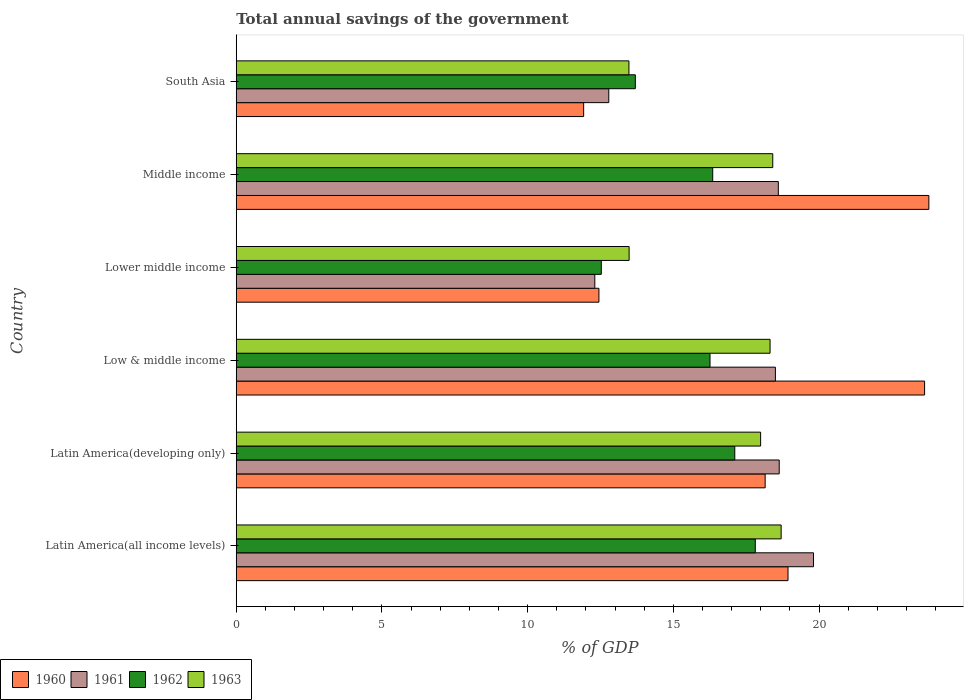How many groups of bars are there?
Offer a terse response. 6. Are the number of bars on each tick of the Y-axis equal?
Ensure brevity in your answer.  Yes. How many bars are there on the 4th tick from the top?
Your answer should be very brief. 4. What is the label of the 5th group of bars from the top?
Offer a terse response. Latin America(developing only). In how many cases, is the number of bars for a given country not equal to the number of legend labels?
Provide a succinct answer. 0. What is the total annual savings of the government in 1961 in Middle income?
Provide a succinct answer. 18.6. Across all countries, what is the maximum total annual savings of the government in 1962?
Offer a terse response. 17.81. Across all countries, what is the minimum total annual savings of the government in 1963?
Your response must be concise. 13.48. In which country was the total annual savings of the government in 1963 maximum?
Your response must be concise. Latin America(all income levels). In which country was the total annual savings of the government in 1963 minimum?
Ensure brevity in your answer.  South Asia. What is the total total annual savings of the government in 1960 in the graph?
Provide a short and direct response. 108.84. What is the difference between the total annual savings of the government in 1961 in Latin America(all income levels) and that in Lower middle income?
Provide a succinct answer. 7.5. What is the difference between the total annual savings of the government in 1962 in South Asia and the total annual savings of the government in 1960 in Latin America(all income levels)?
Give a very brief answer. -5.24. What is the average total annual savings of the government in 1961 per country?
Give a very brief answer. 16.77. What is the difference between the total annual savings of the government in 1963 and total annual savings of the government in 1962 in South Asia?
Your answer should be very brief. -0.22. In how many countries, is the total annual savings of the government in 1962 greater than 18 %?
Your answer should be very brief. 0. What is the ratio of the total annual savings of the government in 1960 in Latin America(all income levels) to that in Latin America(developing only)?
Keep it short and to the point. 1.04. Is the difference between the total annual savings of the government in 1963 in Latin America(developing only) and Low & middle income greater than the difference between the total annual savings of the government in 1962 in Latin America(developing only) and Low & middle income?
Ensure brevity in your answer.  No. What is the difference between the highest and the second highest total annual savings of the government in 1961?
Provide a succinct answer. 1.18. What is the difference between the highest and the lowest total annual savings of the government in 1960?
Give a very brief answer. 11.85. Is the sum of the total annual savings of the government in 1961 in Latin America(all income levels) and Latin America(developing only) greater than the maximum total annual savings of the government in 1960 across all countries?
Your response must be concise. Yes. What does the 3rd bar from the bottom in South Asia represents?
Your answer should be compact. 1962. Is it the case that in every country, the sum of the total annual savings of the government in 1963 and total annual savings of the government in 1961 is greater than the total annual savings of the government in 1960?
Make the answer very short. Yes. How many bars are there?
Your answer should be compact. 24. How many countries are there in the graph?
Your response must be concise. 6. What is the difference between two consecutive major ticks on the X-axis?
Your answer should be very brief. 5. What is the title of the graph?
Keep it short and to the point. Total annual savings of the government. Does "1990" appear as one of the legend labels in the graph?
Make the answer very short. No. What is the label or title of the X-axis?
Ensure brevity in your answer.  % of GDP. What is the % of GDP of 1960 in Latin America(all income levels)?
Offer a terse response. 18.93. What is the % of GDP in 1961 in Latin America(all income levels)?
Offer a very short reply. 19.81. What is the % of GDP in 1962 in Latin America(all income levels)?
Your answer should be compact. 17.81. What is the % of GDP in 1963 in Latin America(all income levels)?
Ensure brevity in your answer.  18.7. What is the % of GDP of 1960 in Latin America(developing only)?
Your response must be concise. 18.15. What is the % of GDP in 1961 in Latin America(developing only)?
Keep it short and to the point. 18.63. What is the % of GDP in 1962 in Latin America(developing only)?
Your response must be concise. 17.11. What is the % of GDP of 1963 in Latin America(developing only)?
Ensure brevity in your answer.  17.99. What is the % of GDP of 1960 in Low & middle income?
Your answer should be compact. 23.62. What is the % of GDP of 1961 in Low & middle income?
Your answer should be very brief. 18.5. What is the % of GDP in 1962 in Low & middle income?
Provide a short and direct response. 16.26. What is the % of GDP in 1963 in Low & middle income?
Ensure brevity in your answer.  18.32. What is the % of GDP of 1960 in Lower middle income?
Your answer should be very brief. 12.45. What is the % of GDP in 1961 in Lower middle income?
Give a very brief answer. 12.3. What is the % of GDP in 1962 in Lower middle income?
Make the answer very short. 12.53. What is the % of GDP in 1963 in Lower middle income?
Give a very brief answer. 13.48. What is the % of GDP in 1960 in Middle income?
Keep it short and to the point. 23.77. What is the % of GDP of 1961 in Middle income?
Keep it short and to the point. 18.6. What is the % of GDP of 1962 in Middle income?
Your response must be concise. 16.35. What is the % of GDP of 1963 in Middle income?
Make the answer very short. 18.41. What is the % of GDP in 1960 in South Asia?
Provide a succinct answer. 11.92. What is the % of GDP in 1961 in South Asia?
Provide a short and direct response. 12.78. What is the % of GDP of 1962 in South Asia?
Give a very brief answer. 13.69. What is the % of GDP in 1963 in South Asia?
Offer a terse response. 13.48. Across all countries, what is the maximum % of GDP in 1960?
Ensure brevity in your answer.  23.77. Across all countries, what is the maximum % of GDP in 1961?
Offer a terse response. 19.81. Across all countries, what is the maximum % of GDP in 1962?
Provide a succinct answer. 17.81. Across all countries, what is the maximum % of GDP of 1963?
Provide a short and direct response. 18.7. Across all countries, what is the minimum % of GDP in 1960?
Provide a short and direct response. 11.92. Across all countries, what is the minimum % of GDP in 1961?
Make the answer very short. 12.3. Across all countries, what is the minimum % of GDP in 1962?
Your answer should be compact. 12.53. Across all countries, what is the minimum % of GDP of 1963?
Ensure brevity in your answer.  13.48. What is the total % of GDP of 1960 in the graph?
Make the answer very short. 108.84. What is the total % of GDP of 1961 in the graph?
Make the answer very short. 100.64. What is the total % of GDP of 1962 in the graph?
Make the answer very short. 93.75. What is the total % of GDP of 1963 in the graph?
Provide a short and direct response. 100.38. What is the difference between the % of GDP of 1960 in Latin America(all income levels) and that in Latin America(developing only)?
Make the answer very short. 0.78. What is the difference between the % of GDP of 1961 in Latin America(all income levels) and that in Latin America(developing only)?
Make the answer very short. 1.18. What is the difference between the % of GDP of 1962 in Latin America(all income levels) and that in Latin America(developing only)?
Make the answer very short. 0.7. What is the difference between the % of GDP in 1963 in Latin America(all income levels) and that in Latin America(developing only)?
Keep it short and to the point. 0.7. What is the difference between the % of GDP of 1960 in Latin America(all income levels) and that in Low & middle income?
Ensure brevity in your answer.  -4.69. What is the difference between the % of GDP in 1961 in Latin America(all income levels) and that in Low & middle income?
Make the answer very short. 1.31. What is the difference between the % of GDP in 1962 in Latin America(all income levels) and that in Low & middle income?
Offer a very short reply. 1.55. What is the difference between the % of GDP in 1963 in Latin America(all income levels) and that in Low & middle income?
Provide a short and direct response. 0.38. What is the difference between the % of GDP of 1960 in Latin America(all income levels) and that in Lower middle income?
Keep it short and to the point. 6.49. What is the difference between the % of GDP in 1961 in Latin America(all income levels) and that in Lower middle income?
Make the answer very short. 7.5. What is the difference between the % of GDP in 1962 in Latin America(all income levels) and that in Lower middle income?
Make the answer very short. 5.28. What is the difference between the % of GDP of 1963 in Latin America(all income levels) and that in Lower middle income?
Provide a succinct answer. 5.22. What is the difference between the % of GDP in 1960 in Latin America(all income levels) and that in Middle income?
Provide a short and direct response. -4.83. What is the difference between the % of GDP in 1961 in Latin America(all income levels) and that in Middle income?
Keep it short and to the point. 1.21. What is the difference between the % of GDP of 1962 in Latin America(all income levels) and that in Middle income?
Ensure brevity in your answer.  1.46. What is the difference between the % of GDP in 1963 in Latin America(all income levels) and that in Middle income?
Make the answer very short. 0.29. What is the difference between the % of GDP of 1960 in Latin America(all income levels) and that in South Asia?
Give a very brief answer. 7.01. What is the difference between the % of GDP in 1961 in Latin America(all income levels) and that in South Asia?
Provide a short and direct response. 7.03. What is the difference between the % of GDP of 1962 in Latin America(all income levels) and that in South Asia?
Provide a short and direct response. 4.12. What is the difference between the % of GDP in 1963 in Latin America(all income levels) and that in South Asia?
Offer a terse response. 5.22. What is the difference between the % of GDP in 1960 in Latin America(developing only) and that in Low & middle income?
Offer a very short reply. -5.47. What is the difference between the % of GDP in 1961 in Latin America(developing only) and that in Low & middle income?
Offer a terse response. 0.13. What is the difference between the % of GDP of 1962 in Latin America(developing only) and that in Low & middle income?
Your answer should be very brief. 0.85. What is the difference between the % of GDP in 1963 in Latin America(developing only) and that in Low & middle income?
Keep it short and to the point. -0.32. What is the difference between the % of GDP in 1960 in Latin America(developing only) and that in Lower middle income?
Your response must be concise. 5.7. What is the difference between the % of GDP in 1961 in Latin America(developing only) and that in Lower middle income?
Your answer should be very brief. 6.33. What is the difference between the % of GDP in 1962 in Latin America(developing only) and that in Lower middle income?
Offer a terse response. 4.58. What is the difference between the % of GDP in 1963 in Latin America(developing only) and that in Lower middle income?
Ensure brevity in your answer.  4.51. What is the difference between the % of GDP of 1960 in Latin America(developing only) and that in Middle income?
Offer a terse response. -5.62. What is the difference between the % of GDP in 1961 in Latin America(developing only) and that in Middle income?
Ensure brevity in your answer.  0.03. What is the difference between the % of GDP of 1962 in Latin America(developing only) and that in Middle income?
Your answer should be very brief. 0.76. What is the difference between the % of GDP in 1963 in Latin America(developing only) and that in Middle income?
Keep it short and to the point. -0.42. What is the difference between the % of GDP in 1960 in Latin America(developing only) and that in South Asia?
Your answer should be compact. 6.23. What is the difference between the % of GDP of 1961 in Latin America(developing only) and that in South Asia?
Keep it short and to the point. 5.85. What is the difference between the % of GDP of 1962 in Latin America(developing only) and that in South Asia?
Your response must be concise. 3.41. What is the difference between the % of GDP of 1963 in Latin America(developing only) and that in South Asia?
Your response must be concise. 4.52. What is the difference between the % of GDP in 1960 in Low & middle income and that in Lower middle income?
Your answer should be compact. 11.18. What is the difference between the % of GDP of 1961 in Low & middle income and that in Lower middle income?
Provide a short and direct response. 6.2. What is the difference between the % of GDP in 1962 in Low & middle income and that in Lower middle income?
Ensure brevity in your answer.  3.73. What is the difference between the % of GDP of 1963 in Low & middle income and that in Lower middle income?
Your response must be concise. 4.84. What is the difference between the % of GDP in 1960 in Low & middle income and that in Middle income?
Your answer should be compact. -0.15. What is the difference between the % of GDP in 1961 in Low & middle income and that in Middle income?
Your response must be concise. -0.1. What is the difference between the % of GDP in 1962 in Low & middle income and that in Middle income?
Provide a short and direct response. -0.09. What is the difference between the % of GDP of 1963 in Low & middle income and that in Middle income?
Give a very brief answer. -0.09. What is the difference between the % of GDP in 1960 in Low & middle income and that in South Asia?
Your answer should be compact. 11.7. What is the difference between the % of GDP of 1961 in Low & middle income and that in South Asia?
Make the answer very short. 5.72. What is the difference between the % of GDP in 1962 in Low & middle income and that in South Asia?
Ensure brevity in your answer.  2.56. What is the difference between the % of GDP in 1963 in Low & middle income and that in South Asia?
Offer a very short reply. 4.84. What is the difference between the % of GDP of 1960 in Lower middle income and that in Middle income?
Give a very brief answer. -11.32. What is the difference between the % of GDP of 1961 in Lower middle income and that in Middle income?
Your answer should be compact. -6.3. What is the difference between the % of GDP of 1962 in Lower middle income and that in Middle income?
Keep it short and to the point. -3.82. What is the difference between the % of GDP in 1963 in Lower middle income and that in Middle income?
Your answer should be compact. -4.93. What is the difference between the % of GDP of 1960 in Lower middle income and that in South Asia?
Keep it short and to the point. 0.52. What is the difference between the % of GDP in 1961 in Lower middle income and that in South Asia?
Offer a terse response. -0.48. What is the difference between the % of GDP in 1962 in Lower middle income and that in South Asia?
Your answer should be compact. -1.17. What is the difference between the % of GDP of 1963 in Lower middle income and that in South Asia?
Give a very brief answer. 0.01. What is the difference between the % of GDP in 1960 in Middle income and that in South Asia?
Provide a succinct answer. 11.85. What is the difference between the % of GDP of 1961 in Middle income and that in South Asia?
Offer a terse response. 5.82. What is the difference between the % of GDP of 1962 in Middle income and that in South Asia?
Provide a short and direct response. 2.66. What is the difference between the % of GDP of 1963 in Middle income and that in South Asia?
Make the answer very short. 4.94. What is the difference between the % of GDP in 1960 in Latin America(all income levels) and the % of GDP in 1961 in Latin America(developing only)?
Your response must be concise. 0.3. What is the difference between the % of GDP of 1960 in Latin America(all income levels) and the % of GDP of 1962 in Latin America(developing only)?
Give a very brief answer. 1.83. What is the difference between the % of GDP in 1960 in Latin America(all income levels) and the % of GDP in 1963 in Latin America(developing only)?
Your response must be concise. 0.94. What is the difference between the % of GDP in 1961 in Latin America(all income levels) and the % of GDP in 1962 in Latin America(developing only)?
Provide a short and direct response. 2.7. What is the difference between the % of GDP in 1961 in Latin America(all income levels) and the % of GDP in 1963 in Latin America(developing only)?
Make the answer very short. 1.81. What is the difference between the % of GDP in 1962 in Latin America(all income levels) and the % of GDP in 1963 in Latin America(developing only)?
Provide a short and direct response. -0.18. What is the difference between the % of GDP of 1960 in Latin America(all income levels) and the % of GDP of 1961 in Low & middle income?
Ensure brevity in your answer.  0.43. What is the difference between the % of GDP in 1960 in Latin America(all income levels) and the % of GDP in 1962 in Low & middle income?
Keep it short and to the point. 2.68. What is the difference between the % of GDP in 1960 in Latin America(all income levels) and the % of GDP in 1963 in Low & middle income?
Give a very brief answer. 0.62. What is the difference between the % of GDP of 1961 in Latin America(all income levels) and the % of GDP of 1962 in Low & middle income?
Your answer should be very brief. 3.55. What is the difference between the % of GDP in 1961 in Latin America(all income levels) and the % of GDP in 1963 in Low & middle income?
Your answer should be very brief. 1.49. What is the difference between the % of GDP in 1962 in Latin America(all income levels) and the % of GDP in 1963 in Low & middle income?
Give a very brief answer. -0.51. What is the difference between the % of GDP in 1960 in Latin America(all income levels) and the % of GDP in 1961 in Lower middle income?
Your answer should be compact. 6.63. What is the difference between the % of GDP in 1960 in Latin America(all income levels) and the % of GDP in 1962 in Lower middle income?
Offer a very short reply. 6.41. What is the difference between the % of GDP in 1960 in Latin America(all income levels) and the % of GDP in 1963 in Lower middle income?
Keep it short and to the point. 5.45. What is the difference between the % of GDP in 1961 in Latin America(all income levels) and the % of GDP in 1962 in Lower middle income?
Make the answer very short. 7.28. What is the difference between the % of GDP in 1961 in Latin America(all income levels) and the % of GDP in 1963 in Lower middle income?
Your answer should be compact. 6.33. What is the difference between the % of GDP of 1962 in Latin America(all income levels) and the % of GDP of 1963 in Lower middle income?
Your answer should be compact. 4.33. What is the difference between the % of GDP of 1960 in Latin America(all income levels) and the % of GDP of 1961 in Middle income?
Your answer should be very brief. 0.33. What is the difference between the % of GDP in 1960 in Latin America(all income levels) and the % of GDP in 1962 in Middle income?
Offer a terse response. 2.58. What is the difference between the % of GDP in 1960 in Latin America(all income levels) and the % of GDP in 1963 in Middle income?
Your response must be concise. 0.52. What is the difference between the % of GDP of 1961 in Latin America(all income levels) and the % of GDP of 1962 in Middle income?
Offer a very short reply. 3.46. What is the difference between the % of GDP of 1961 in Latin America(all income levels) and the % of GDP of 1963 in Middle income?
Your response must be concise. 1.4. What is the difference between the % of GDP of 1962 in Latin America(all income levels) and the % of GDP of 1963 in Middle income?
Offer a very short reply. -0.6. What is the difference between the % of GDP of 1960 in Latin America(all income levels) and the % of GDP of 1961 in South Asia?
Make the answer very short. 6.15. What is the difference between the % of GDP in 1960 in Latin America(all income levels) and the % of GDP in 1962 in South Asia?
Ensure brevity in your answer.  5.24. What is the difference between the % of GDP of 1960 in Latin America(all income levels) and the % of GDP of 1963 in South Asia?
Ensure brevity in your answer.  5.46. What is the difference between the % of GDP in 1961 in Latin America(all income levels) and the % of GDP in 1962 in South Asia?
Offer a very short reply. 6.11. What is the difference between the % of GDP in 1961 in Latin America(all income levels) and the % of GDP in 1963 in South Asia?
Offer a terse response. 6.33. What is the difference between the % of GDP in 1962 in Latin America(all income levels) and the % of GDP in 1963 in South Asia?
Your response must be concise. 4.34. What is the difference between the % of GDP of 1960 in Latin America(developing only) and the % of GDP of 1961 in Low & middle income?
Ensure brevity in your answer.  -0.35. What is the difference between the % of GDP of 1960 in Latin America(developing only) and the % of GDP of 1962 in Low & middle income?
Your answer should be very brief. 1.89. What is the difference between the % of GDP in 1960 in Latin America(developing only) and the % of GDP in 1963 in Low & middle income?
Your answer should be compact. -0.17. What is the difference between the % of GDP of 1961 in Latin America(developing only) and the % of GDP of 1962 in Low & middle income?
Offer a terse response. 2.37. What is the difference between the % of GDP of 1961 in Latin America(developing only) and the % of GDP of 1963 in Low & middle income?
Provide a short and direct response. 0.31. What is the difference between the % of GDP of 1962 in Latin America(developing only) and the % of GDP of 1963 in Low & middle income?
Make the answer very short. -1.21. What is the difference between the % of GDP of 1960 in Latin America(developing only) and the % of GDP of 1961 in Lower middle income?
Make the answer very short. 5.85. What is the difference between the % of GDP of 1960 in Latin America(developing only) and the % of GDP of 1962 in Lower middle income?
Provide a short and direct response. 5.62. What is the difference between the % of GDP in 1960 in Latin America(developing only) and the % of GDP in 1963 in Lower middle income?
Provide a succinct answer. 4.67. What is the difference between the % of GDP of 1961 in Latin America(developing only) and the % of GDP of 1962 in Lower middle income?
Your response must be concise. 6.11. What is the difference between the % of GDP of 1961 in Latin America(developing only) and the % of GDP of 1963 in Lower middle income?
Your answer should be compact. 5.15. What is the difference between the % of GDP of 1962 in Latin America(developing only) and the % of GDP of 1963 in Lower middle income?
Your response must be concise. 3.63. What is the difference between the % of GDP in 1960 in Latin America(developing only) and the % of GDP in 1961 in Middle income?
Your answer should be compact. -0.45. What is the difference between the % of GDP of 1960 in Latin America(developing only) and the % of GDP of 1962 in Middle income?
Your response must be concise. 1.8. What is the difference between the % of GDP in 1960 in Latin America(developing only) and the % of GDP in 1963 in Middle income?
Keep it short and to the point. -0.26. What is the difference between the % of GDP of 1961 in Latin America(developing only) and the % of GDP of 1962 in Middle income?
Your answer should be compact. 2.28. What is the difference between the % of GDP of 1961 in Latin America(developing only) and the % of GDP of 1963 in Middle income?
Ensure brevity in your answer.  0.22. What is the difference between the % of GDP of 1962 in Latin America(developing only) and the % of GDP of 1963 in Middle income?
Provide a short and direct response. -1.3. What is the difference between the % of GDP in 1960 in Latin America(developing only) and the % of GDP in 1961 in South Asia?
Your response must be concise. 5.37. What is the difference between the % of GDP in 1960 in Latin America(developing only) and the % of GDP in 1962 in South Asia?
Keep it short and to the point. 4.46. What is the difference between the % of GDP in 1960 in Latin America(developing only) and the % of GDP in 1963 in South Asia?
Your answer should be very brief. 4.67. What is the difference between the % of GDP of 1961 in Latin America(developing only) and the % of GDP of 1962 in South Asia?
Ensure brevity in your answer.  4.94. What is the difference between the % of GDP in 1961 in Latin America(developing only) and the % of GDP in 1963 in South Asia?
Offer a very short reply. 5.16. What is the difference between the % of GDP of 1962 in Latin America(developing only) and the % of GDP of 1963 in South Asia?
Give a very brief answer. 3.63. What is the difference between the % of GDP in 1960 in Low & middle income and the % of GDP in 1961 in Lower middle income?
Your response must be concise. 11.32. What is the difference between the % of GDP of 1960 in Low & middle income and the % of GDP of 1962 in Lower middle income?
Offer a terse response. 11.09. What is the difference between the % of GDP of 1960 in Low & middle income and the % of GDP of 1963 in Lower middle income?
Give a very brief answer. 10.14. What is the difference between the % of GDP in 1961 in Low & middle income and the % of GDP in 1962 in Lower middle income?
Your answer should be very brief. 5.97. What is the difference between the % of GDP of 1961 in Low & middle income and the % of GDP of 1963 in Lower middle income?
Your answer should be very brief. 5.02. What is the difference between the % of GDP in 1962 in Low & middle income and the % of GDP in 1963 in Lower middle income?
Your answer should be very brief. 2.78. What is the difference between the % of GDP of 1960 in Low & middle income and the % of GDP of 1961 in Middle income?
Your response must be concise. 5.02. What is the difference between the % of GDP of 1960 in Low & middle income and the % of GDP of 1962 in Middle income?
Your response must be concise. 7.27. What is the difference between the % of GDP of 1960 in Low & middle income and the % of GDP of 1963 in Middle income?
Ensure brevity in your answer.  5.21. What is the difference between the % of GDP in 1961 in Low & middle income and the % of GDP in 1962 in Middle income?
Give a very brief answer. 2.15. What is the difference between the % of GDP of 1961 in Low & middle income and the % of GDP of 1963 in Middle income?
Provide a short and direct response. 0.09. What is the difference between the % of GDP in 1962 in Low & middle income and the % of GDP in 1963 in Middle income?
Provide a short and direct response. -2.15. What is the difference between the % of GDP in 1960 in Low & middle income and the % of GDP in 1961 in South Asia?
Your response must be concise. 10.84. What is the difference between the % of GDP in 1960 in Low & middle income and the % of GDP in 1962 in South Asia?
Keep it short and to the point. 9.93. What is the difference between the % of GDP in 1960 in Low & middle income and the % of GDP in 1963 in South Asia?
Offer a terse response. 10.15. What is the difference between the % of GDP of 1961 in Low & middle income and the % of GDP of 1962 in South Asia?
Make the answer very short. 4.81. What is the difference between the % of GDP of 1961 in Low & middle income and the % of GDP of 1963 in South Asia?
Your answer should be compact. 5.03. What is the difference between the % of GDP in 1962 in Low & middle income and the % of GDP in 1963 in South Asia?
Your response must be concise. 2.78. What is the difference between the % of GDP in 1960 in Lower middle income and the % of GDP in 1961 in Middle income?
Keep it short and to the point. -6.16. What is the difference between the % of GDP in 1960 in Lower middle income and the % of GDP in 1962 in Middle income?
Keep it short and to the point. -3.9. What is the difference between the % of GDP of 1960 in Lower middle income and the % of GDP of 1963 in Middle income?
Make the answer very short. -5.97. What is the difference between the % of GDP of 1961 in Lower middle income and the % of GDP of 1962 in Middle income?
Your answer should be compact. -4.05. What is the difference between the % of GDP in 1961 in Lower middle income and the % of GDP in 1963 in Middle income?
Give a very brief answer. -6.11. What is the difference between the % of GDP of 1962 in Lower middle income and the % of GDP of 1963 in Middle income?
Your response must be concise. -5.88. What is the difference between the % of GDP of 1960 in Lower middle income and the % of GDP of 1961 in South Asia?
Your answer should be very brief. -0.34. What is the difference between the % of GDP of 1960 in Lower middle income and the % of GDP of 1962 in South Asia?
Your answer should be very brief. -1.25. What is the difference between the % of GDP in 1960 in Lower middle income and the % of GDP in 1963 in South Asia?
Your response must be concise. -1.03. What is the difference between the % of GDP of 1961 in Lower middle income and the % of GDP of 1962 in South Asia?
Your answer should be compact. -1.39. What is the difference between the % of GDP of 1961 in Lower middle income and the % of GDP of 1963 in South Asia?
Offer a terse response. -1.17. What is the difference between the % of GDP in 1962 in Lower middle income and the % of GDP in 1963 in South Asia?
Your answer should be compact. -0.95. What is the difference between the % of GDP in 1960 in Middle income and the % of GDP in 1961 in South Asia?
Provide a succinct answer. 10.98. What is the difference between the % of GDP in 1960 in Middle income and the % of GDP in 1962 in South Asia?
Offer a very short reply. 10.07. What is the difference between the % of GDP of 1960 in Middle income and the % of GDP of 1963 in South Asia?
Keep it short and to the point. 10.29. What is the difference between the % of GDP of 1961 in Middle income and the % of GDP of 1962 in South Asia?
Your answer should be very brief. 4.91. What is the difference between the % of GDP of 1961 in Middle income and the % of GDP of 1963 in South Asia?
Make the answer very short. 5.13. What is the difference between the % of GDP of 1962 in Middle income and the % of GDP of 1963 in South Asia?
Offer a very short reply. 2.88. What is the average % of GDP of 1960 per country?
Your answer should be very brief. 18.14. What is the average % of GDP of 1961 per country?
Keep it short and to the point. 16.77. What is the average % of GDP of 1962 per country?
Ensure brevity in your answer.  15.63. What is the average % of GDP in 1963 per country?
Make the answer very short. 16.73. What is the difference between the % of GDP in 1960 and % of GDP in 1961 in Latin America(all income levels)?
Make the answer very short. -0.87. What is the difference between the % of GDP of 1960 and % of GDP of 1962 in Latin America(all income levels)?
Provide a short and direct response. 1.12. What is the difference between the % of GDP of 1960 and % of GDP of 1963 in Latin America(all income levels)?
Provide a succinct answer. 0.24. What is the difference between the % of GDP of 1961 and % of GDP of 1962 in Latin America(all income levels)?
Provide a short and direct response. 2. What is the difference between the % of GDP of 1961 and % of GDP of 1963 in Latin America(all income levels)?
Ensure brevity in your answer.  1.11. What is the difference between the % of GDP of 1962 and % of GDP of 1963 in Latin America(all income levels)?
Make the answer very short. -0.89. What is the difference between the % of GDP in 1960 and % of GDP in 1961 in Latin America(developing only)?
Provide a short and direct response. -0.48. What is the difference between the % of GDP of 1960 and % of GDP of 1962 in Latin America(developing only)?
Your answer should be very brief. 1.04. What is the difference between the % of GDP of 1960 and % of GDP of 1963 in Latin America(developing only)?
Your response must be concise. 0.16. What is the difference between the % of GDP in 1961 and % of GDP in 1962 in Latin America(developing only)?
Provide a short and direct response. 1.52. What is the difference between the % of GDP in 1961 and % of GDP in 1963 in Latin America(developing only)?
Offer a very short reply. 0.64. What is the difference between the % of GDP in 1962 and % of GDP in 1963 in Latin America(developing only)?
Your response must be concise. -0.89. What is the difference between the % of GDP of 1960 and % of GDP of 1961 in Low & middle income?
Offer a very short reply. 5.12. What is the difference between the % of GDP of 1960 and % of GDP of 1962 in Low & middle income?
Offer a terse response. 7.36. What is the difference between the % of GDP of 1960 and % of GDP of 1963 in Low & middle income?
Provide a short and direct response. 5.3. What is the difference between the % of GDP in 1961 and % of GDP in 1962 in Low & middle income?
Provide a succinct answer. 2.24. What is the difference between the % of GDP of 1961 and % of GDP of 1963 in Low & middle income?
Keep it short and to the point. 0.18. What is the difference between the % of GDP in 1962 and % of GDP in 1963 in Low & middle income?
Offer a very short reply. -2.06. What is the difference between the % of GDP in 1960 and % of GDP in 1961 in Lower middle income?
Offer a very short reply. 0.14. What is the difference between the % of GDP in 1960 and % of GDP in 1962 in Lower middle income?
Your response must be concise. -0.08. What is the difference between the % of GDP of 1960 and % of GDP of 1963 in Lower middle income?
Give a very brief answer. -1.04. What is the difference between the % of GDP in 1961 and % of GDP in 1962 in Lower middle income?
Keep it short and to the point. -0.22. What is the difference between the % of GDP in 1961 and % of GDP in 1963 in Lower middle income?
Your answer should be compact. -1.18. What is the difference between the % of GDP of 1962 and % of GDP of 1963 in Lower middle income?
Your answer should be very brief. -0.95. What is the difference between the % of GDP in 1960 and % of GDP in 1961 in Middle income?
Ensure brevity in your answer.  5.17. What is the difference between the % of GDP in 1960 and % of GDP in 1962 in Middle income?
Keep it short and to the point. 7.42. What is the difference between the % of GDP of 1960 and % of GDP of 1963 in Middle income?
Your response must be concise. 5.36. What is the difference between the % of GDP of 1961 and % of GDP of 1962 in Middle income?
Your answer should be very brief. 2.25. What is the difference between the % of GDP of 1961 and % of GDP of 1963 in Middle income?
Offer a terse response. 0.19. What is the difference between the % of GDP in 1962 and % of GDP in 1963 in Middle income?
Provide a succinct answer. -2.06. What is the difference between the % of GDP in 1960 and % of GDP in 1961 in South Asia?
Your response must be concise. -0.86. What is the difference between the % of GDP in 1960 and % of GDP in 1962 in South Asia?
Keep it short and to the point. -1.77. What is the difference between the % of GDP of 1960 and % of GDP of 1963 in South Asia?
Ensure brevity in your answer.  -1.55. What is the difference between the % of GDP of 1961 and % of GDP of 1962 in South Asia?
Your response must be concise. -0.91. What is the difference between the % of GDP of 1961 and % of GDP of 1963 in South Asia?
Give a very brief answer. -0.69. What is the difference between the % of GDP in 1962 and % of GDP in 1963 in South Asia?
Give a very brief answer. 0.22. What is the ratio of the % of GDP in 1960 in Latin America(all income levels) to that in Latin America(developing only)?
Your answer should be very brief. 1.04. What is the ratio of the % of GDP of 1961 in Latin America(all income levels) to that in Latin America(developing only)?
Provide a short and direct response. 1.06. What is the ratio of the % of GDP of 1962 in Latin America(all income levels) to that in Latin America(developing only)?
Your answer should be very brief. 1.04. What is the ratio of the % of GDP in 1963 in Latin America(all income levels) to that in Latin America(developing only)?
Provide a short and direct response. 1.04. What is the ratio of the % of GDP in 1960 in Latin America(all income levels) to that in Low & middle income?
Ensure brevity in your answer.  0.8. What is the ratio of the % of GDP in 1961 in Latin America(all income levels) to that in Low & middle income?
Make the answer very short. 1.07. What is the ratio of the % of GDP in 1962 in Latin America(all income levels) to that in Low & middle income?
Give a very brief answer. 1.1. What is the ratio of the % of GDP of 1963 in Latin America(all income levels) to that in Low & middle income?
Provide a short and direct response. 1.02. What is the ratio of the % of GDP in 1960 in Latin America(all income levels) to that in Lower middle income?
Your answer should be compact. 1.52. What is the ratio of the % of GDP of 1961 in Latin America(all income levels) to that in Lower middle income?
Give a very brief answer. 1.61. What is the ratio of the % of GDP of 1962 in Latin America(all income levels) to that in Lower middle income?
Give a very brief answer. 1.42. What is the ratio of the % of GDP in 1963 in Latin America(all income levels) to that in Lower middle income?
Offer a very short reply. 1.39. What is the ratio of the % of GDP in 1960 in Latin America(all income levels) to that in Middle income?
Offer a terse response. 0.8. What is the ratio of the % of GDP in 1961 in Latin America(all income levels) to that in Middle income?
Make the answer very short. 1.06. What is the ratio of the % of GDP of 1962 in Latin America(all income levels) to that in Middle income?
Provide a short and direct response. 1.09. What is the ratio of the % of GDP of 1963 in Latin America(all income levels) to that in Middle income?
Your response must be concise. 1.02. What is the ratio of the % of GDP in 1960 in Latin America(all income levels) to that in South Asia?
Your response must be concise. 1.59. What is the ratio of the % of GDP of 1961 in Latin America(all income levels) to that in South Asia?
Offer a very short reply. 1.55. What is the ratio of the % of GDP of 1962 in Latin America(all income levels) to that in South Asia?
Provide a short and direct response. 1.3. What is the ratio of the % of GDP in 1963 in Latin America(all income levels) to that in South Asia?
Your answer should be compact. 1.39. What is the ratio of the % of GDP in 1960 in Latin America(developing only) to that in Low & middle income?
Make the answer very short. 0.77. What is the ratio of the % of GDP of 1961 in Latin America(developing only) to that in Low & middle income?
Keep it short and to the point. 1.01. What is the ratio of the % of GDP in 1962 in Latin America(developing only) to that in Low & middle income?
Provide a short and direct response. 1.05. What is the ratio of the % of GDP of 1963 in Latin America(developing only) to that in Low & middle income?
Your answer should be very brief. 0.98. What is the ratio of the % of GDP of 1960 in Latin America(developing only) to that in Lower middle income?
Your answer should be very brief. 1.46. What is the ratio of the % of GDP of 1961 in Latin America(developing only) to that in Lower middle income?
Offer a very short reply. 1.51. What is the ratio of the % of GDP in 1962 in Latin America(developing only) to that in Lower middle income?
Provide a short and direct response. 1.37. What is the ratio of the % of GDP in 1963 in Latin America(developing only) to that in Lower middle income?
Your answer should be very brief. 1.33. What is the ratio of the % of GDP of 1960 in Latin America(developing only) to that in Middle income?
Provide a succinct answer. 0.76. What is the ratio of the % of GDP in 1961 in Latin America(developing only) to that in Middle income?
Keep it short and to the point. 1. What is the ratio of the % of GDP in 1962 in Latin America(developing only) to that in Middle income?
Make the answer very short. 1.05. What is the ratio of the % of GDP in 1963 in Latin America(developing only) to that in Middle income?
Make the answer very short. 0.98. What is the ratio of the % of GDP in 1960 in Latin America(developing only) to that in South Asia?
Keep it short and to the point. 1.52. What is the ratio of the % of GDP in 1961 in Latin America(developing only) to that in South Asia?
Offer a terse response. 1.46. What is the ratio of the % of GDP in 1962 in Latin America(developing only) to that in South Asia?
Make the answer very short. 1.25. What is the ratio of the % of GDP in 1963 in Latin America(developing only) to that in South Asia?
Provide a short and direct response. 1.34. What is the ratio of the % of GDP in 1960 in Low & middle income to that in Lower middle income?
Keep it short and to the point. 1.9. What is the ratio of the % of GDP in 1961 in Low & middle income to that in Lower middle income?
Provide a succinct answer. 1.5. What is the ratio of the % of GDP in 1962 in Low & middle income to that in Lower middle income?
Provide a succinct answer. 1.3. What is the ratio of the % of GDP of 1963 in Low & middle income to that in Lower middle income?
Keep it short and to the point. 1.36. What is the ratio of the % of GDP in 1961 in Low & middle income to that in Middle income?
Your response must be concise. 0.99. What is the ratio of the % of GDP of 1963 in Low & middle income to that in Middle income?
Provide a succinct answer. 0.99. What is the ratio of the % of GDP in 1960 in Low & middle income to that in South Asia?
Offer a terse response. 1.98. What is the ratio of the % of GDP in 1961 in Low & middle income to that in South Asia?
Offer a terse response. 1.45. What is the ratio of the % of GDP in 1962 in Low & middle income to that in South Asia?
Make the answer very short. 1.19. What is the ratio of the % of GDP of 1963 in Low & middle income to that in South Asia?
Ensure brevity in your answer.  1.36. What is the ratio of the % of GDP in 1960 in Lower middle income to that in Middle income?
Offer a terse response. 0.52. What is the ratio of the % of GDP in 1961 in Lower middle income to that in Middle income?
Your response must be concise. 0.66. What is the ratio of the % of GDP of 1962 in Lower middle income to that in Middle income?
Provide a succinct answer. 0.77. What is the ratio of the % of GDP in 1963 in Lower middle income to that in Middle income?
Ensure brevity in your answer.  0.73. What is the ratio of the % of GDP in 1960 in Lower middle income to that in South Asia?
Offer a terse response. 1.04. What is the ratio of the % of GDP of 1961 in Lower middle income to that in South Asia?
Your answer should be compact. 0.96. What is the ratio of the % of GDP in 1962 in Lower middle income to that in South Asia?
Make the answer very short. 0.91. What is the ratio of the % of GDP in 1960 in Middle income to that in South Asia?
Your answer should be very brief. 1.99. What is the ratio of the % of GDP of 1961 in Middle income to that in South Asia?
Your response must be concise. 1.46. What is the ratio of the % of GDP of 1962 in Middle income to that in South Asia?
Offer a terse response. 1.19. What is the ratio of the % of GDP in 1963 in Middle income to that in South Asia?
Your answer should be very brief. 1.37. What is the difference between the highest and the second highest % of GDP in 1960?
Make the answer very short. 0.15. What is the difference between the highest and the second highest % of GDP of 1961?
Offer a terse response. 1.18. What is the difference between the highest and the second highest % of GDP in 1962?
Your answer should be compact. 0.7. What is the difference between the highest and the second highest % of GDP of 1963?
Your answer should be compact. 0.29. What is the difference between the highest and the lowest % of GDP in 1960?
Provide a short and direct response. 11.85. What is the difference between the highest and the lowest % of GDP of 1961?
Keep it short and to the point. 7.5. What is the difference between the highest and the lowest % of GDP in 1962?
Provide a succinct answer. 5.28. What is the difference between the highest and the lowest % of GDP in 1963?
Provide a succinct answer. 5.22. 